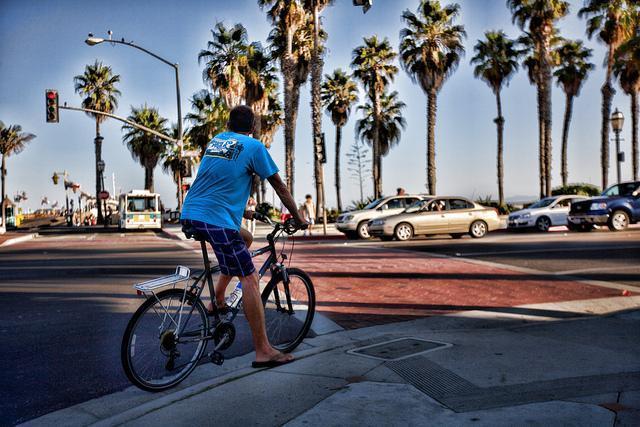How many cars are there?
Give a very brief answer. 4. How many police cars are in this picture?
Give a very brief answer. 0. How many bikes are there?
Give a very brief answer. 1. 